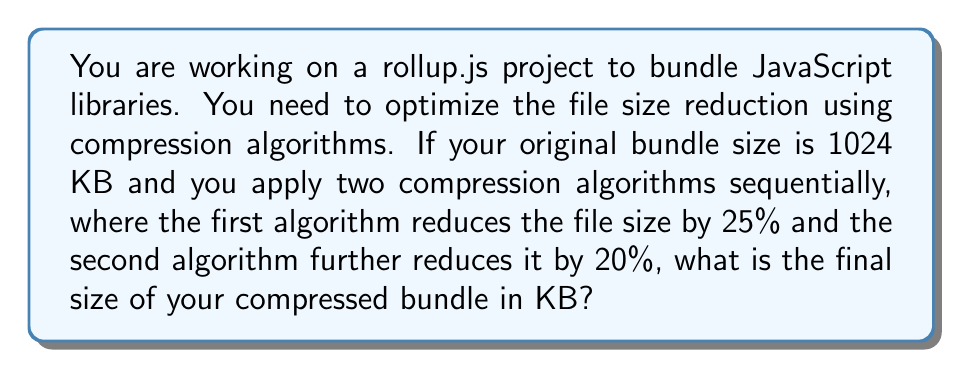Can you solve this math problem? Let's approach this step-by-step:

1) Start with the original bundle size:
   $$S_0 = 1024 \text{ KB}$$

2) Apply the first compression algorithm (25% reduction):
   $$S_1 = S_0 \times (1 - 0.25) = 1024 \times 0.75 = 768 \text{ KB}$$

3) Apply the second compression algorithm (20% reduction) to the result of the first compression:
   $$S_2 = S_1 \times (1 - 0.20) = 768 \times 0.80 = 614.4 \text{ KB}$$

4) The final size is 614.4 KB.

Note: The order of applying the compression algorithms matters. If we had applied them in reverse order, the result would have been different:

$$1024 \times (1 - 0.20) \times (1 - 0.25) = 1024 \times 0.80 \times 0.75 = 614.4 \text{ KB}$$

In this case, it happens to yield the same result, but this is not always true for different compression ratios.
Answer: 614.4 KB 